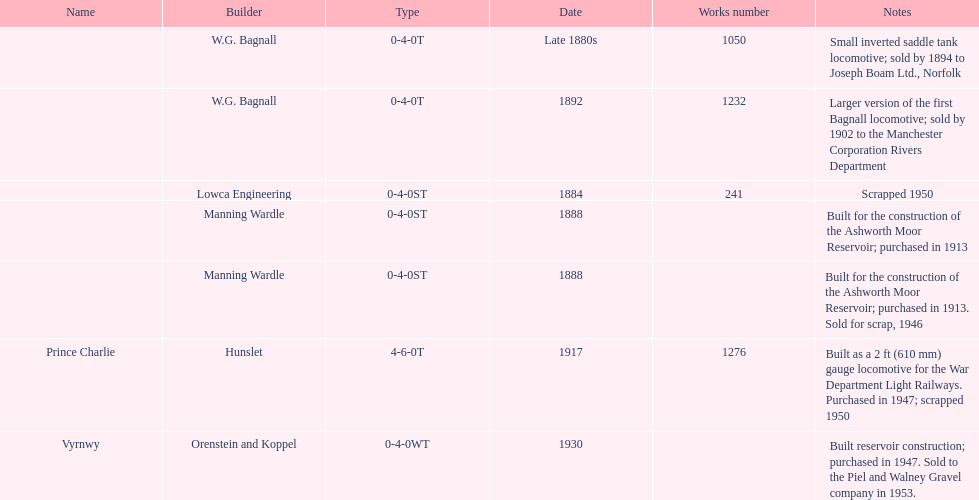Who built the larger version of the first bagnall locomotive? W.G. Bagnall. 